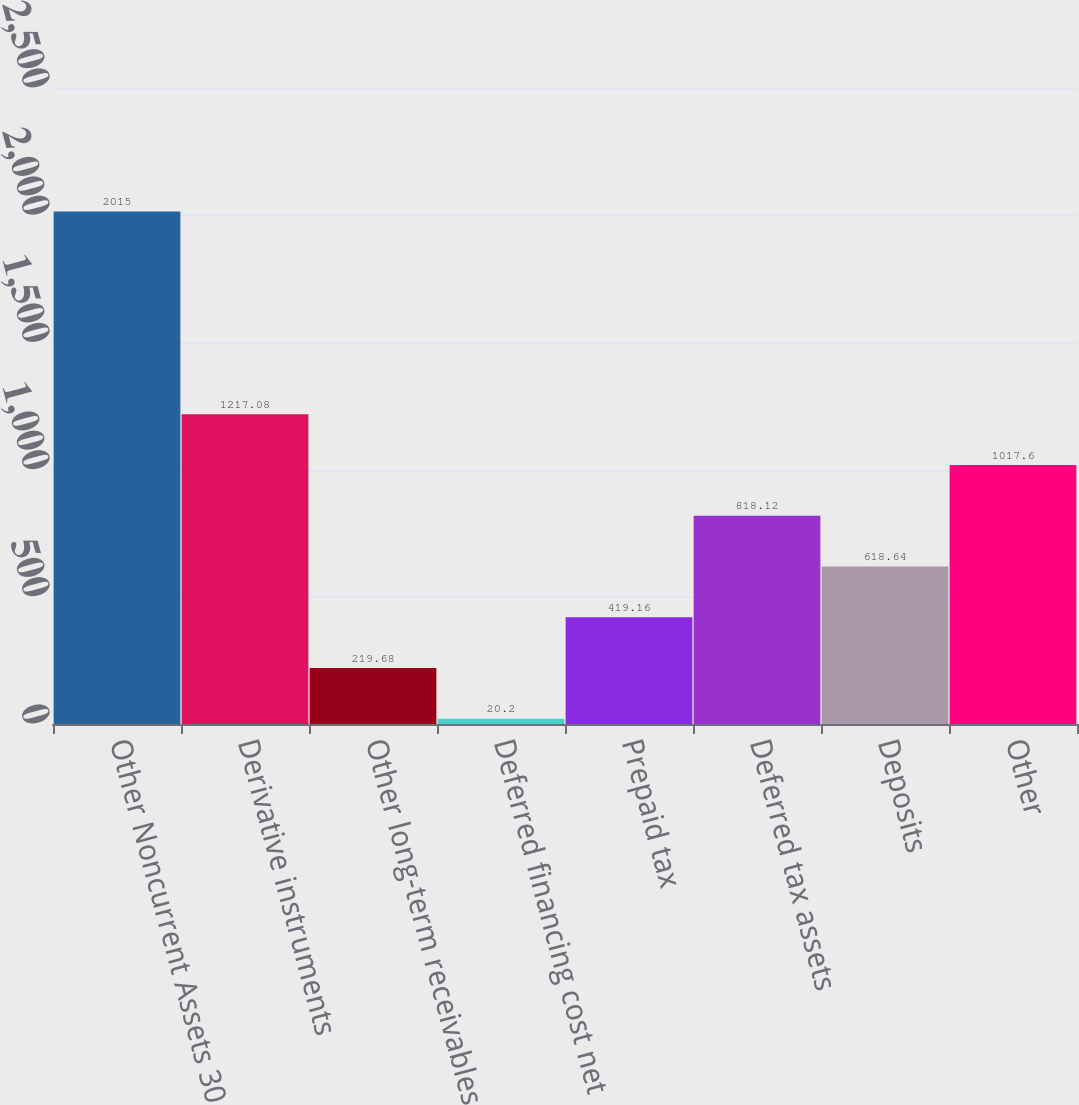Convert chart. <chart><loc_0><loc_0><loc_500><loc_500><bar_chart><fcel>Other Noncurrent Assets 30<fcel>Derivative instruments<fcel>Other long-term receivables<fcel>Deferred financing cost net<fcel>Prepaid tax<fcel>Deferred tax assets<fcel>Deposits<fcel>Other<nl><fcel>2015<fcel>1217.08<fcel>219.68<fcel>20.2<fcel>419.16<fcel>818.12<fcel>618.64<fcel>1017.6<nl></chart> 